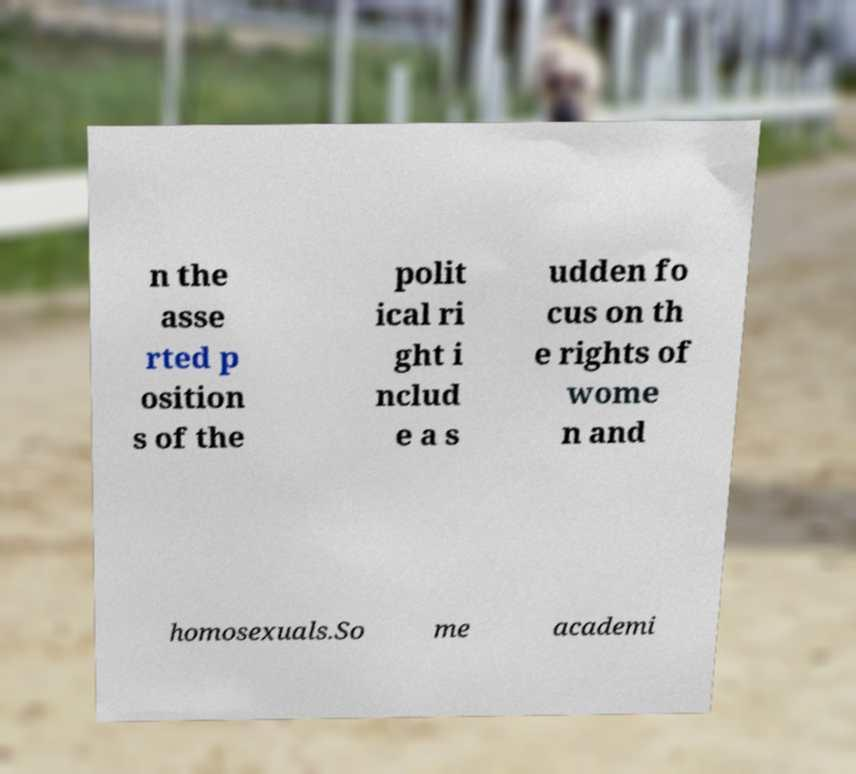I need the written content from this picture converted into text. Can you do that? n the asse rted p osition s of the polit ical ri ght i nclud e a s udden fo cus on th e rights of wome n and homosexuals.So me academi 